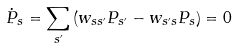<formula> <loc_0><loc_0><loc_500><loc_500>\dot { P } _ { s } = \sum _ { s ^ { \prime } } \left ( w _ { s s ^ { \prime } } P _ { s ^ { \prime } } - w _ { s ^ { \prime } s } P _ { s } \right ) = 0</formula> 